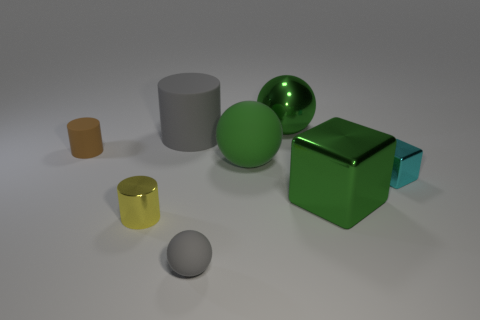There is a big sphere that is in front of the large green sphere that is behind the large green rubber sphere; what is its material?
Provide a succinct answer. Rubber. What is the shape of the cyan metal thing?
Provide a short and direct response. Cube. There is a large green object that is the same shape as the cyan metal thing; what is its material?
Make the answer very short. Metal. What number of gray rubber balls are the same size as the cyan thing?
Provide a short and direct response. 1. Is there a tiny gray thing that is behind the big thing left of the large matte ball?
Provide a short and direct response. No. How many red things are cylinders or metallic spheres?
Your answer should be compact. 0. What is the color of the large metal ball?
Offer a very short reply. Green. What is the size of the green object that is made of the same material as the tiny brown thing?
Offer a terse response. Large. What number of big brown shiny objects are the same shape as the tiny cyan object?
Your response must be concise. 0. Are there any other things that are the same size as the cyan cube?
Your answer should be very brief. Yes. 